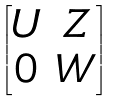<formula> <loc_0><loc_0><loc_500><loc_500>\begin{bmatrix} U & Z \\ 0 & W \end{bmatrix}</formula> 